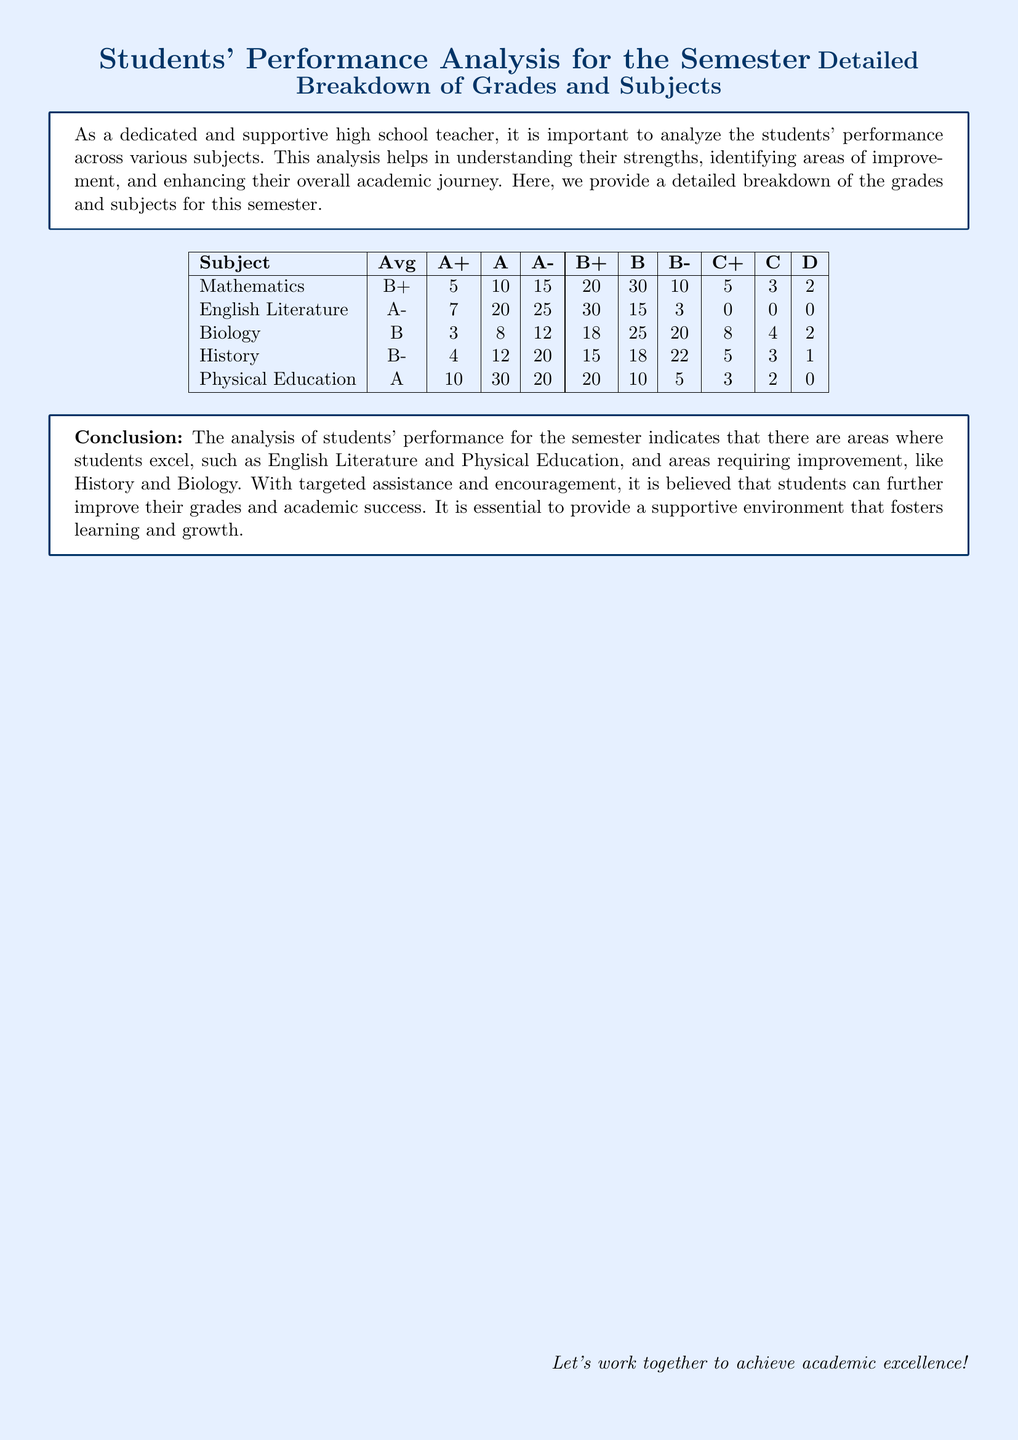What is the average grade in Mathematics? The average grade for Mathematics is listed in the table, which shows "B+".
Answer: B+ How many students received an A in English Literature? The table indicates the number of students who received an A in English Literature, which is 20.
Answer: 20 Which subject had the highest average grade? By comparing the averages provided, Physical Education has the highest average grade, which is "A".
Answer: A How many students received a D in Biology? The table specifies that 2 students received a D in Biology.
Answer: 2 What is the average grade in History? The document includes the average grade for History, which is "B-".
Answer: B- Which subject requires improvement according to the conclusion? The conclusion specifically identifies subjects needing improvement, such as History and Biology.
Answer: History and Biology How many students received an A+ in Physical Education? According to the table, 10 students received an A+ in Physical Education.
Answer: 10 What is the total number of students who received a grade of B in Biology? The breakdown shows that 25 students received a B in Biology.
Answer: 25 What is mentioned as essential for improving students' performance? The conclusion emphasizes the importance of providing a supportive environment for learning and growth.
Answer: Supportive environment 